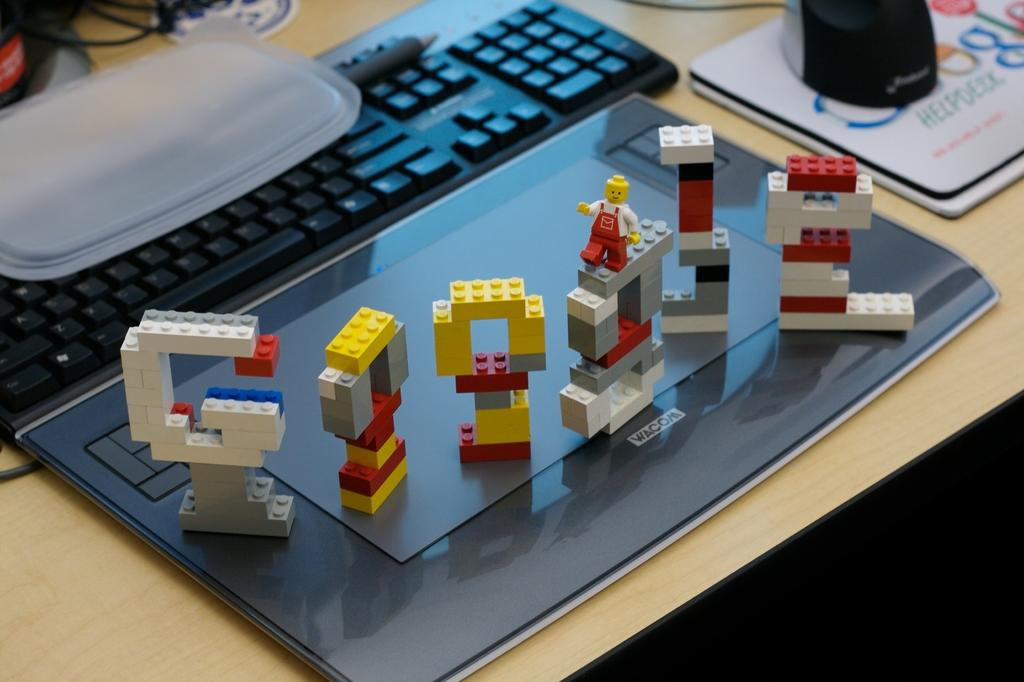What objects can be seen on the surface in the image? There are toys on the surface in the image. What electronic device is present in the image? There is a keyboard in the image. What type of object is connected to the keyboard? There is a wire in the image. What material is used to make one of the objects in the image? There is a wooden object in the image. Can you see a guitar being played in the image? There is no guitar or anyone playing a guitar in the image. Are the toys in the image kissing each other? The toys in the image are not kissing each other; they are simply placed on the surface. 